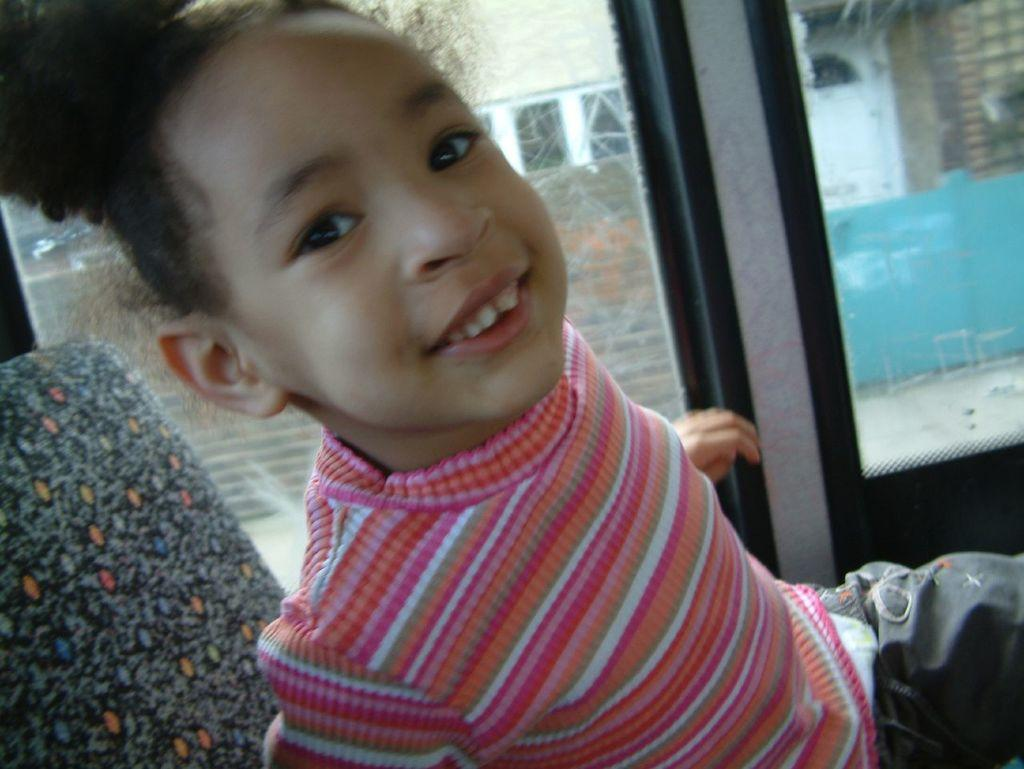What is the main subject of the image? The main subject of the image is a kid. What is the kid doing in the image? The kid is sitting on a chair in the image. What can be seen in the background of the image? There is a glass window in the background of the image. What type of chin can be seen on the art displayed on the wall in the image? There is no art displayed on the wall in the image, and therefore no chin can be seen. 